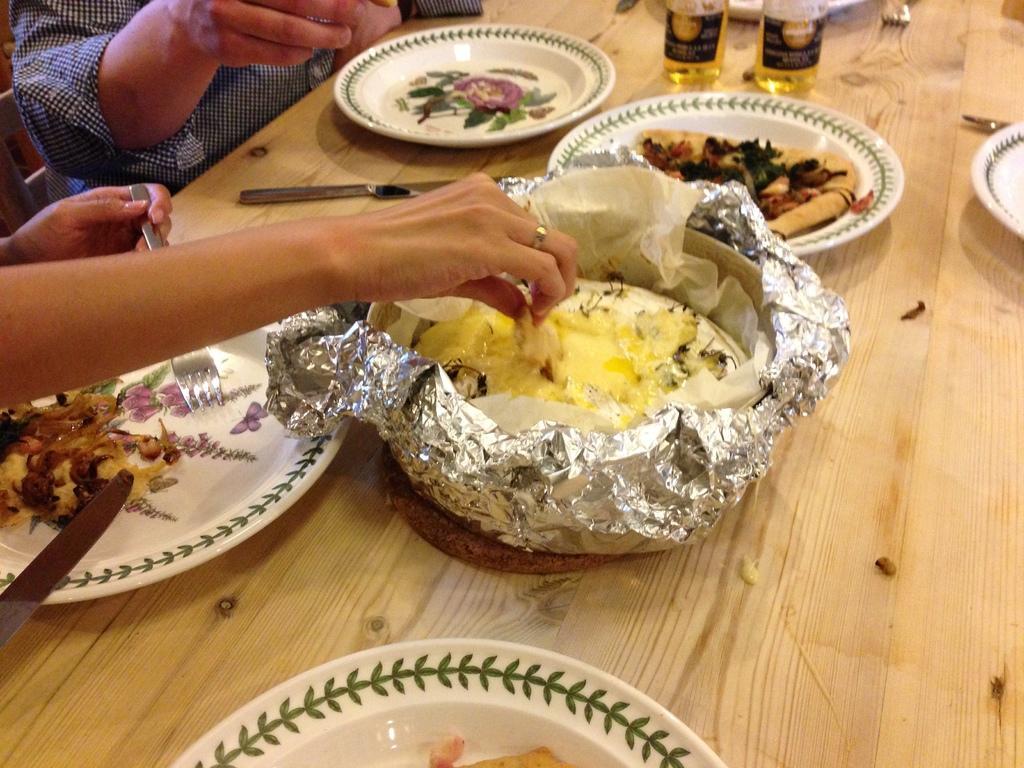Could you give a brief overview of what you see in this image? This image is taken indoors. At the bottom of the image there is a table with a few plates, a knife, two bottles and a bowl with a food item on it and there are pizza slices on the plate. On the left side of the image two persons are sitting on the chairs and a person is holding a knife and food in the hands. 